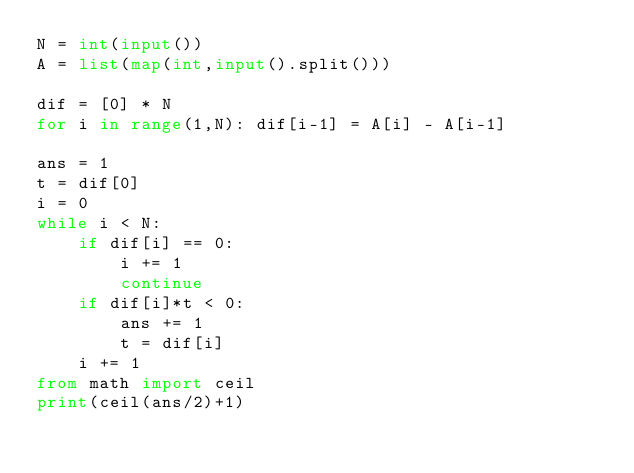Convert code to text. <code><loc_0><loc_0><loc_500><loc_500><_Python_>N = int(input())
A = list(map(int,input().split()))

dif = [0] * N
for i in range(1,N): dif[i-1] = A[i] - A[i-1]

ans = 1
t = dif[0]
i = 0
while i < N:
    if dif[i] == 0:
        i += 1
        continue
    if dif[i]*t < 0:
        ans += 1
        t = dif[i]
    i += 1
from math import ceil
print(ceil(ans/2)+1)</code> 